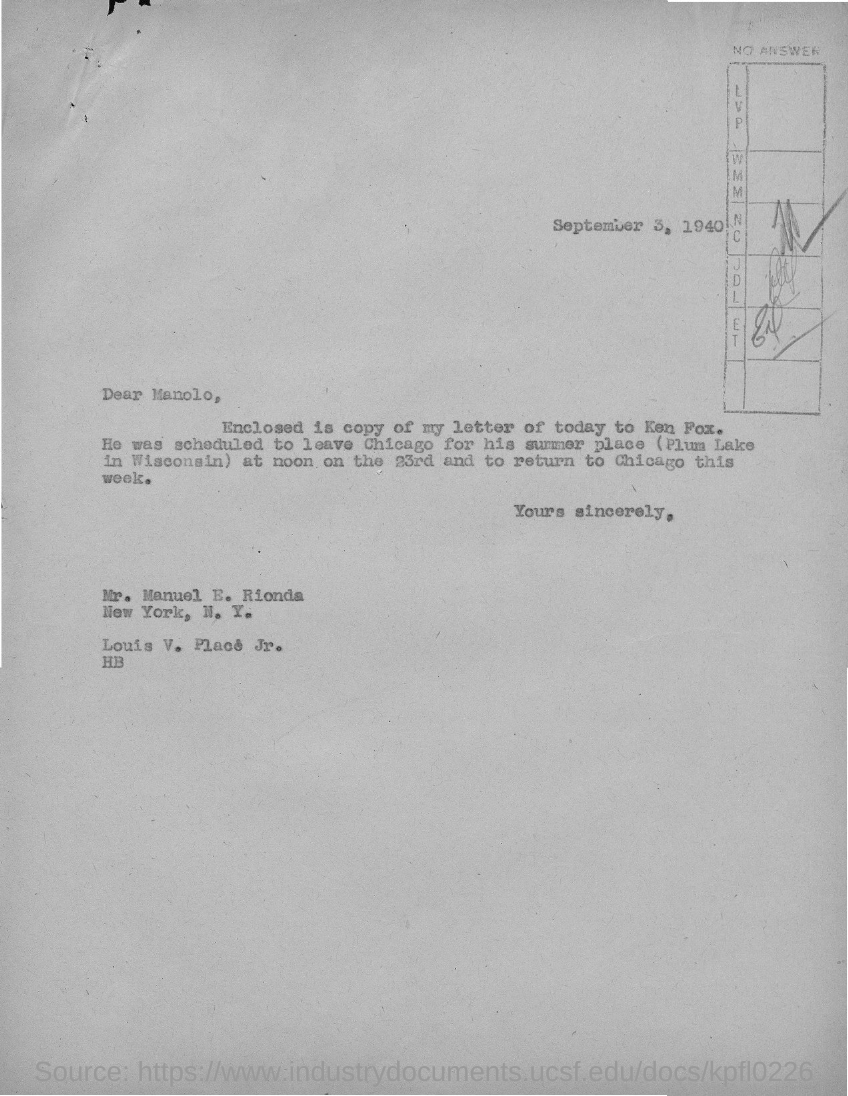Give some essential details in this illustration. The letter was sent to Mr. Manuel E. Rionda. The date mentioned in the given page is September 3, 1940. 